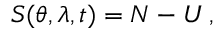<formula> <loc_0><loc_0><loc_500><loc_500>S ( \theta , \lambda , t ) = N - U \, ,</formula> 